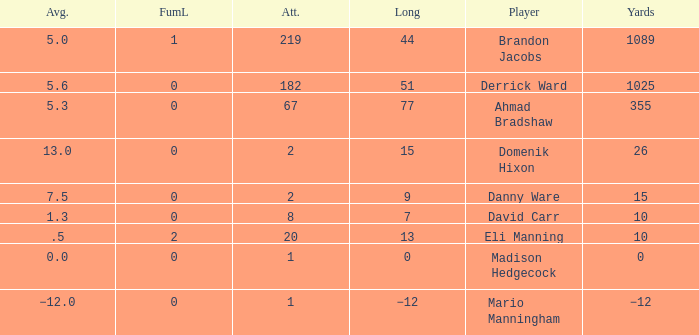What is Domenik Hixon's average rush? 13.0. 